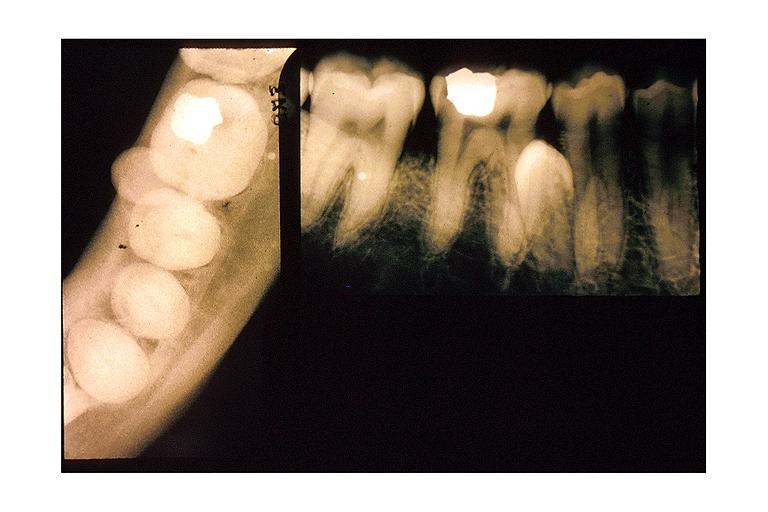where is this?
Answer the question using a single word or phrase. Oral 